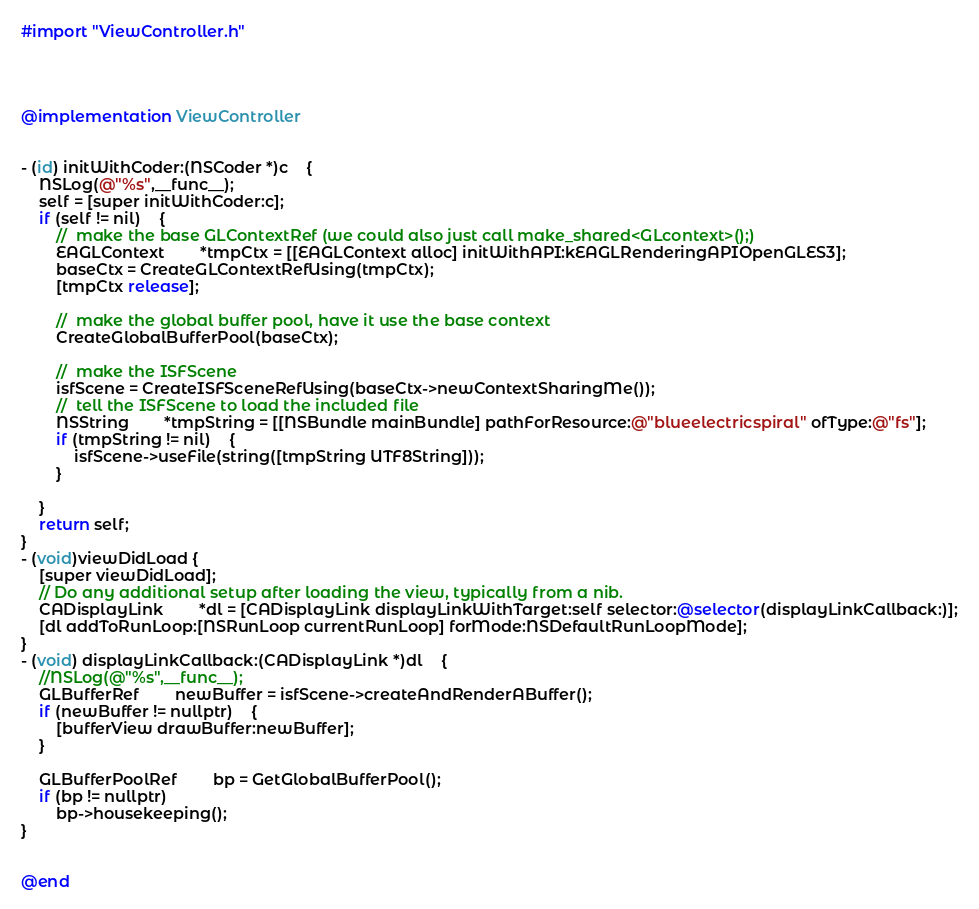<code> <loc_0><loc_0><loc_500><loc_500><_ObjectiveC_>#import "ViewController.h"




@implementation ViewController


- (id) initWithCoder:(NSCoder *)c	{
	NSLog(@"%s",__func__);
	self = [super initWithCoder:c];
	if (self != nil)	{
		//	make the base GLContextRef (we could also just call make_shared<GLcontext>();)
		EAGLContext		*tmpCtx = [[EAGLContext alloc] initWithAPI:kEAGLRenderingAPIOpenGLES3];
		baseCtx = CreateGLContextRefUsing(tmpCtx);
		[tmpCtx release];
		
		//	make the global buffer pool, have it use the base context
		CreateGlobalBufferPool(baseCtx);
		
		//	make the ISFScene
		isfScene = CreateISFSceneRefUsing(baseCtx->newContextSharingMe());
		//	tell the ISFScene to load the included file
		NSString		*tmpString = [[NSBundle mainBundle] pathForResource:@"blueelectricspiral" ofType:@"fs"];
		if (tmpString != nil)	{
			isfScene->useFile(string([tmpString UTF8String]));
		}
		
	}
	return self;
}
- (void)viewDidLoad {
	[super viewDidLoad];
	// Do any additional setup after loading the view, typically from a nib.
	CADisplayLink		*dl = [CADisplayLink displayLinkWithTarget:self selector:@selector(displayLinkCallback:)];
	[dl addToRunLoop:[NSRunLoop currentRunLoop] forMode:NSDefaultRunLoopMode];
}
- (void) displayLinkCallback:(CADisplayLink *)dl	{
	//NSLog(@"%s",__func__);
	GLBufferRef		newBuffer = isfScene->createAndRenderABuffer();
	if (newBuffer != nullptr)	{
		[bufferView drawBuffer:newBuffer];
	}
	
	GLBufferPoolRef		bp = GetGlobalBufferPool();
	if (bp != nullptr)
		bp->housekeeping();
}


@end
</code> 